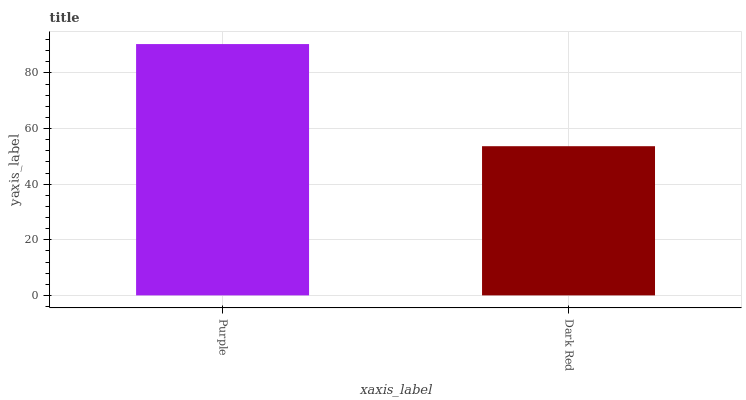Is Dark Red the minimum?
Answer yes or no. Yes. Is Purple the maximum?
Answer yes or no. Yes. Is Dark Red the maximum?
Answer yes or no. No. Is Purple greater than Dark Red?
Answer yes or no. Yes. Is Dark Red less than Purple?
Answer yes or no. Yes. Is Dark Red greater than Purple?
Answer yes or no. No. Is Purple less than Dark Red?
Answer yes or no. No. Is Purple the high median?
Answer yes or no. Yes. Is Dark Red the low median?
Answer yes or no. Yes. Is Dark Red the high median?
Answer yes or no. No. Is Purple the low median?
Answer yes or no. No. 